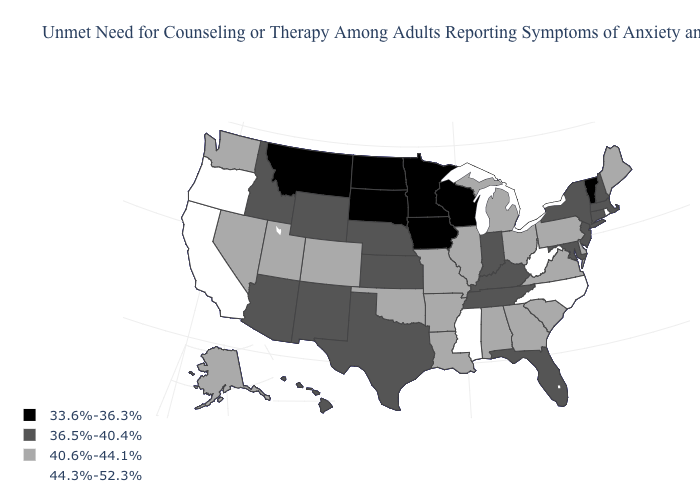Name the states that have a value in the range 36.5%-40.4%?
Short answer required. Arizona, Connecticut, Florida, Hawaii, Idaho, Indiana, Kansas, Kentucky, Maryland, Massachusetts, Nebraska, New Hampshire, New Jersey, New Mexico, New York, Tennessee, Texas, Wyoming. What is the value of Missouri?
Give a very brief answer. 40.6%-44.1%. Name the states that have a value in the range 33.6%-36.3%?
Short answer required. Iowa, Minnesota, Montana, North Dakota, South Dakota, Vermont, Wisconsin. What is the value of North Dakota?
Give a very brief answer. 33.6%-36.3%. Name the states that have a value in the range 44.3%-52.3%?
Give a very brief answer. California, Mississippi, North Carolina, Oregon, Rhode Island, West Virginia. Which states have the highest value in the USA?
Write a very short answer. California, Mississippi, North Carolina, Oregon, Rhode Island, West Virginia. What is the value of New York?
Answer briefly. 36.5%-40.4%. Does the map have missing data?
Answer briefly. No. Name the states that have a value in the range 40.6%-44.1%?
Short answer required. Alabama, Alaska, Arkansas, Colorado, Delaware, Georgia, Illinois, Louisiana, Maine, Michigan, Missouri, Nevada, Ohio, Oklahoma, Pennsylvania, South Carolina, Utah, Virginia, Washington. What is the value of Alabama?
Be succinct. 40.6%-44.1%. Name the states that have a value in the range 44.3%-52.3%?
Give a very brief answer. California, Mississippi, North Carolina, Oregon, Rhode Island, West Virginia. Name the states that have a value in the range 33.6%-36.3%?
Be succinct. Iowa, Minnesota, Montana, North Dakota, South Dakota, Vermont, Wisconsin. What is the value of Ohio?
Quick response, please. 40.6%-44.1%. How many symbols are there in the legend?
Short answer required. 4. Name the states that have a value in the range 44.3%-52.3%?
Concise answer only. California, Mississippi, North Carolina, Oregon, Rhode Island, West Virginia. 